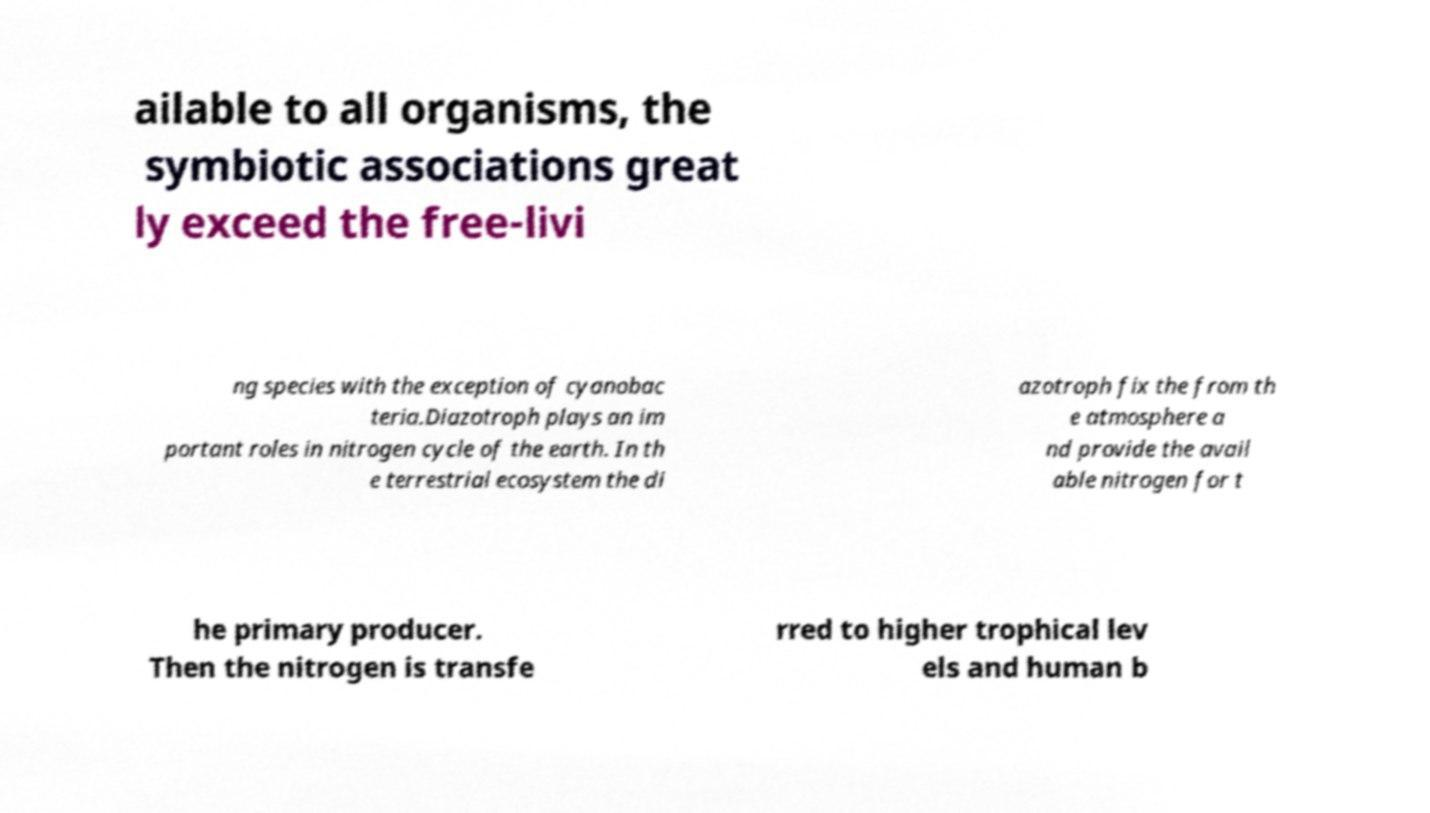Could you assist in decoding the text presented in this image and type it out clearly? ailable to all organisms, the symbiotic associations great ly exceed the free-livi ng species with the exception of cyanobac teria.Diazotroph plays an im portant roles in nitrogen cycle of the earth. In th e terrestrial ecosystem the di azotroph fix the from th e atmosphere a nd provide the avail able nitrogen for t he primary producer. Then the nitrogen is transfe rred to higher trophical lev els and human b 